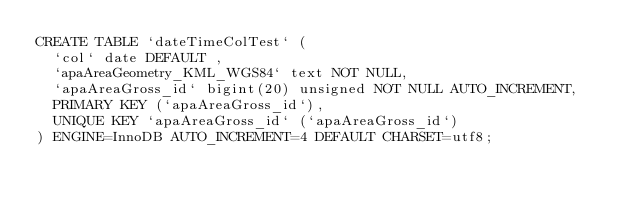<code> <loc_0><loc_0><loc_500><loc_500><_SQL_>CREATE TABLE `dateTimeColTest` (
  `col` date DEFAULT ,
  `apaAreaGeometry_KML_WGS84` text NOT NULL,
  `apaAreaGross_id` bigint(20) unsigned NOT NULL AUTO_INCREMENT,
  PRIMARY KEY (`apaAreaGross_id`),
  UNIQUE KEY `apaAreaGross_id` (`apaAreaGross_id`)
) ENGINE=InnoDB AUTO_INCREMENT=4 DEFAULT CHARSET=utf8;
</code> 